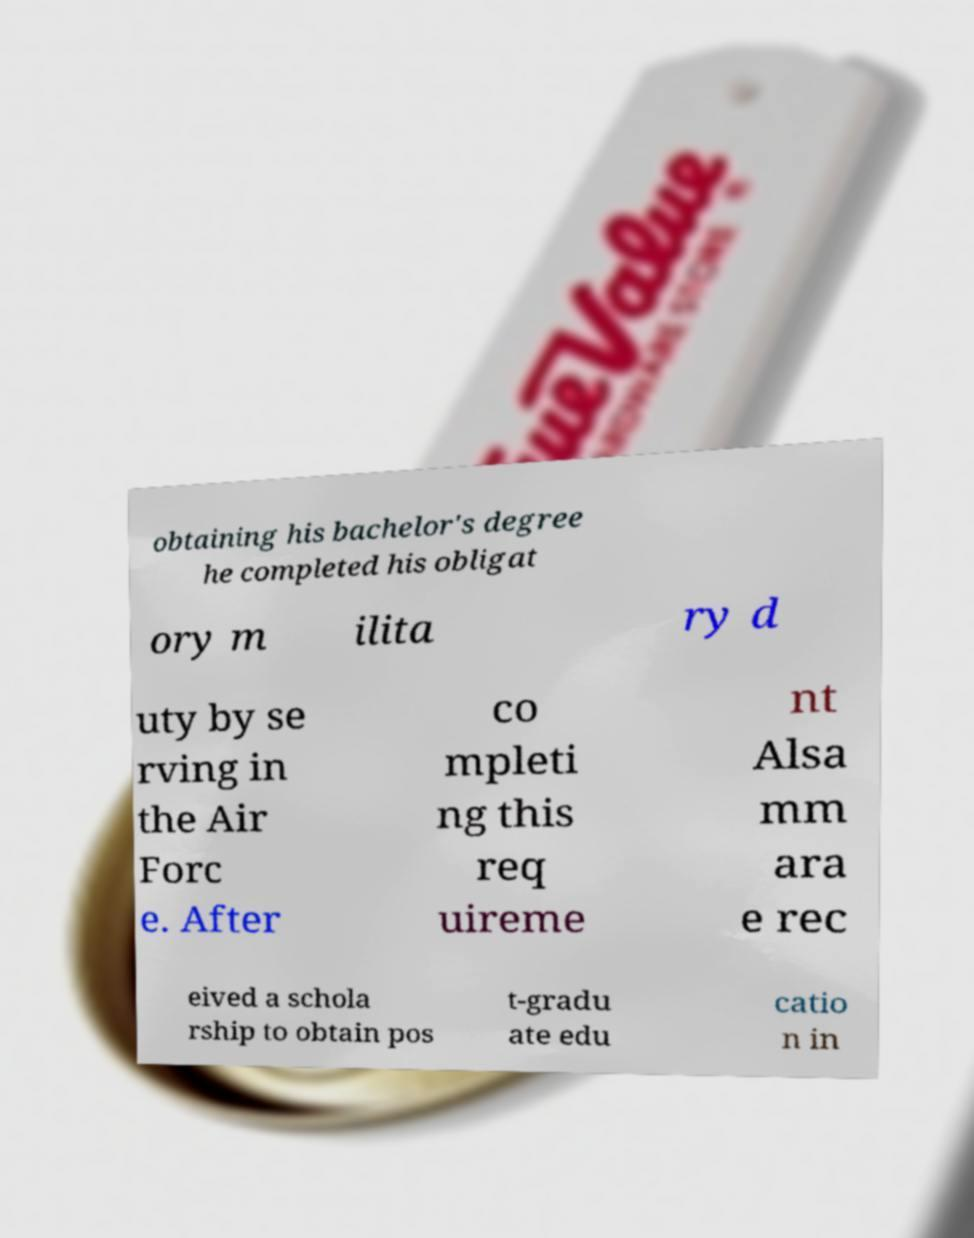Could you assist in decoding the text presented in this image and type it out clearly? obtaining his bachelor's degree he completed his obligat ory m ilita ry d uty by se rving in the Air Forc e. After co mpleti ng this req uireme nt Alsa mm ara e rec eived a schola rship to obtain pos t-gradu ate edu catio n in 